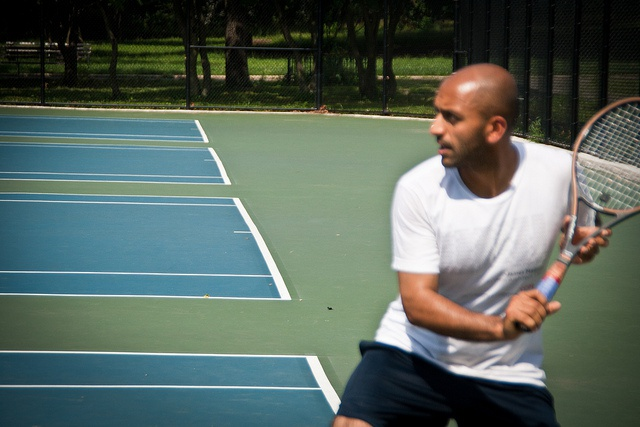Describe the objects in this image and their specific colors. I can see people in black, lightgray, gray, and darkgray tones and tennis racket in black, gray, and darkgray tones in this image. 